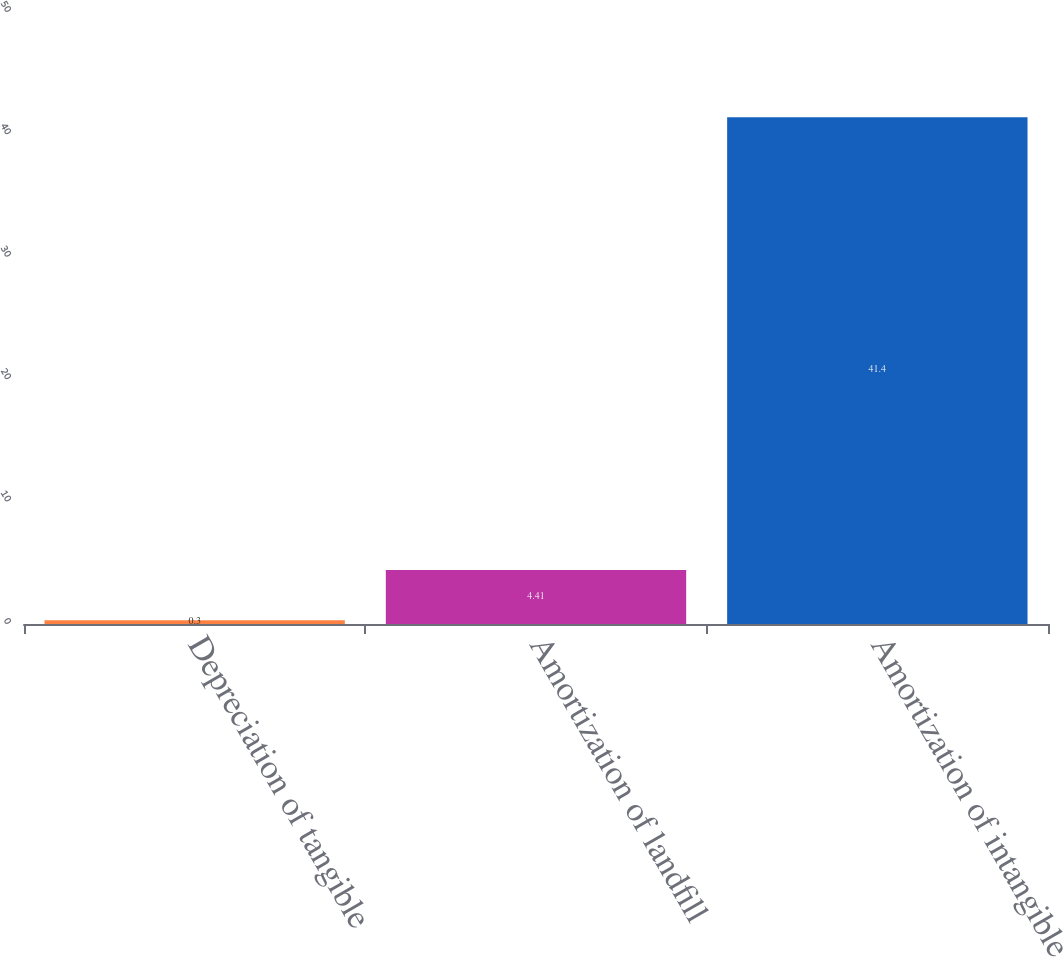<chart> <loc_0><loc_0><loc_500><loc_500><bar_chart><fcel>Depreciation of tangible<fcel>Amortization of landfill<fcel>Amortization of intangible<nl><fcel>0.3<fcel>4.41<fcel>41.4<nl></chart> 